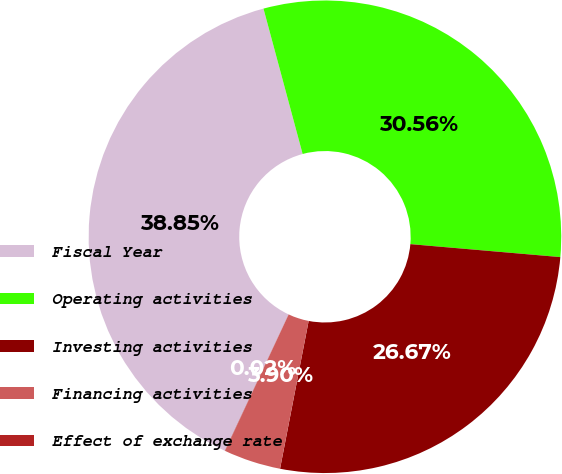Convert chart. <chart><loc_0><loc_0><loc_500><loc_500><pie_chart><fcel>Fiscal Year<fcel>Operating activities<fcel>Investing activities<fcel>Financing activities<fcel>Effect of exchange rate<nl><fcel>38.85%<fcel>30.56%<fcel>26.67%<fcel>3.9%<fcel>0.02%<nl></chart> 